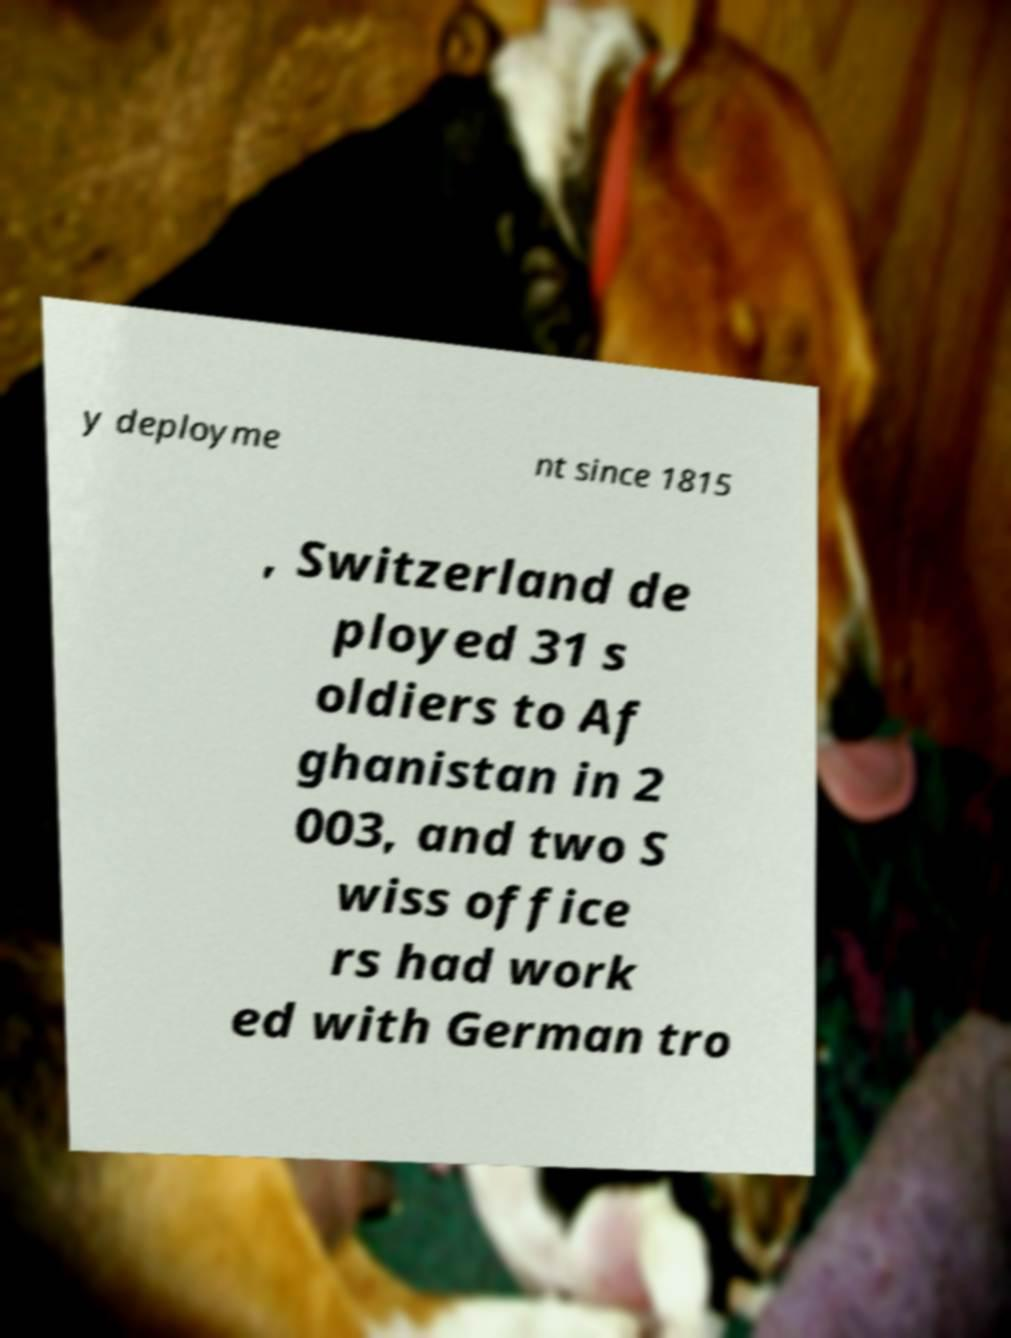Could you extract and type out the text from this image? y deployme nt since 1815 , Switzerland de ployed 31 s oldiers to Af ghanistan in 2 003, and two S wiss office rs had work ed with German tro 